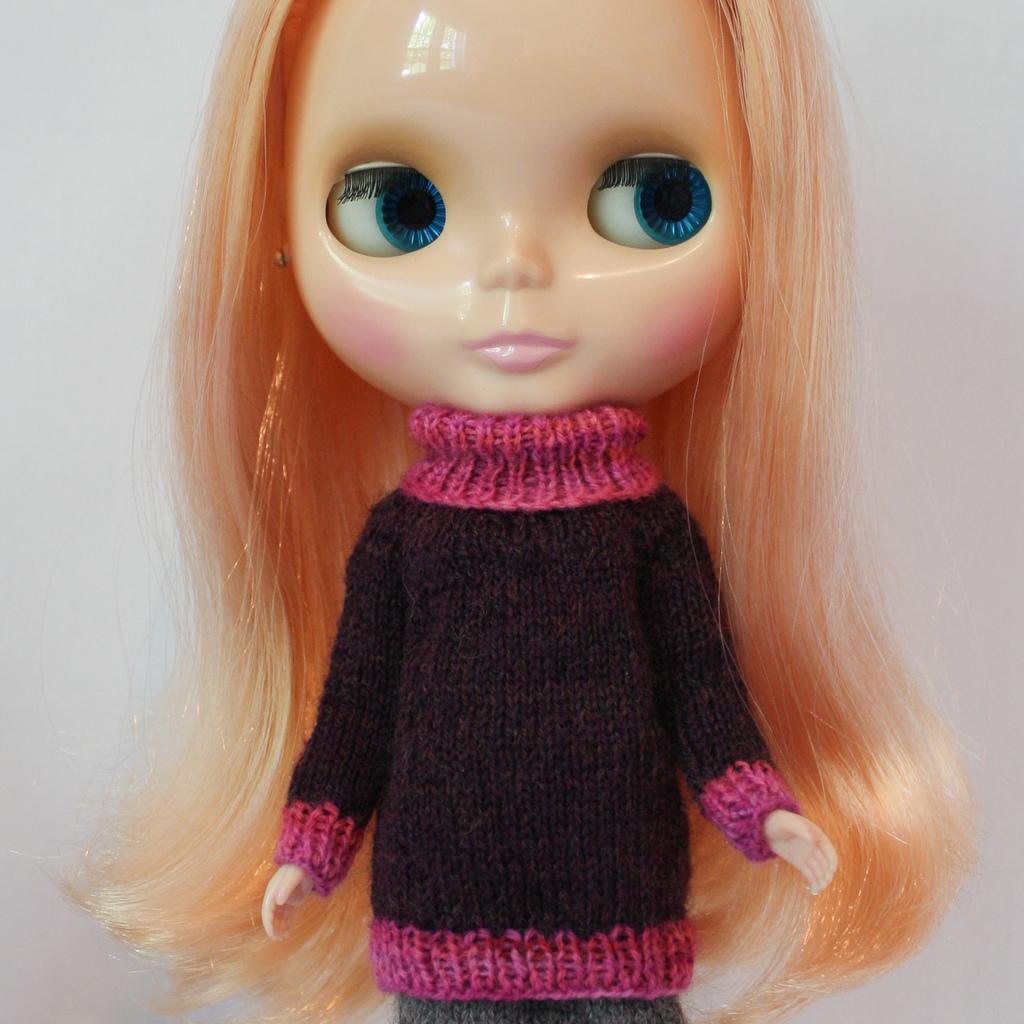Describe this image in one or two sentences. In this image we can see a girl you, here are the eyes, here is the nose, at back here is the wall. 